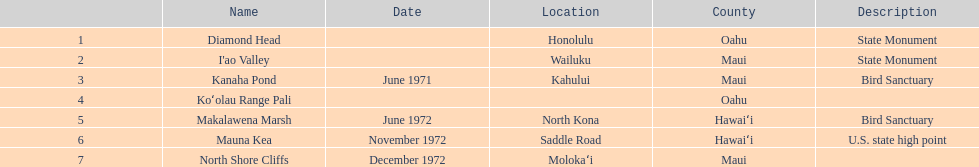What are the natural landmarks in hawaii(national)? Diamond Head, I'ao Valley, Kanaha Pond, Koʻolau Range Pali, Makalawena Marsh, Mauna Kea, North Shore Cliffs. Of these which is described as a u.s state high point? Mauna Kea. 